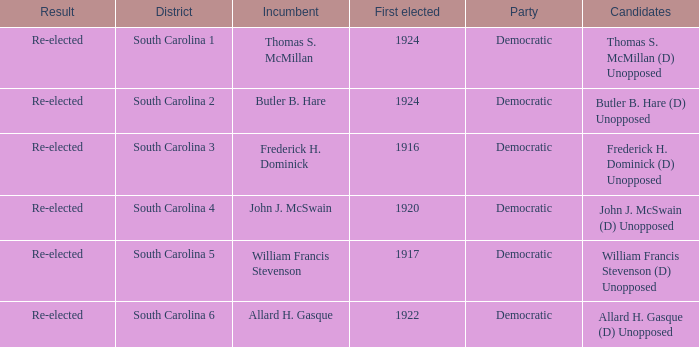What year was william francis stevenson first elected? 1917.0. 